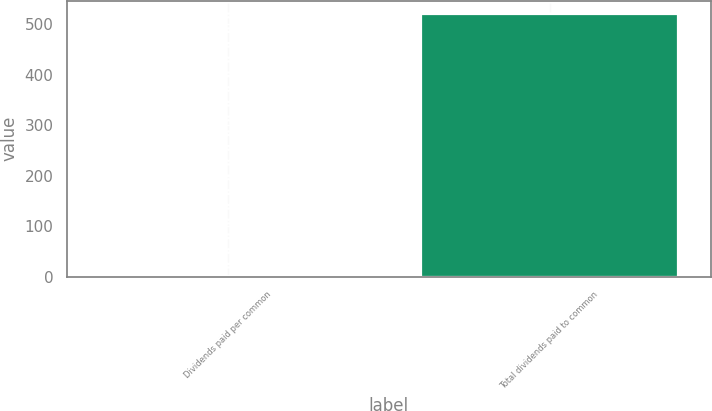Convert chart. <chart><loc_0><loc_0><loc_500><loc_500><bar_chart><fcel>Dividends paid per common<fcel>Total dividends paid to common<nl><fcel>1.34<fcel>521<nl></chart> 